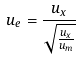Convert formula to latex. <formula><loc_0><loc_0><loc_500><loc_500>u _ { e } = \frac { u _ { x } } { \sqrt { \frac { u _ { x } } { u _ { m } } } }</formula> 